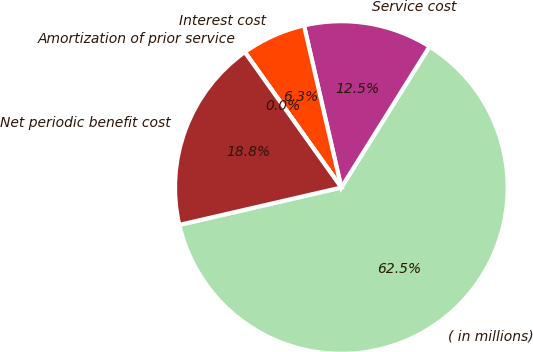<chart> <loc_0><loc_0><loc_500><loc_500><pie_chart><fcel>( in millions)<fcel>Service cost<fcel>Interest cost<fcel>Amortization of prior service<fcel>Net periodic benefit cost<nl><fcel>62.49%<fcel>12.5%<fcel>6.25%<fcel>0.0%<fcel>18.75%<nl></chart> 